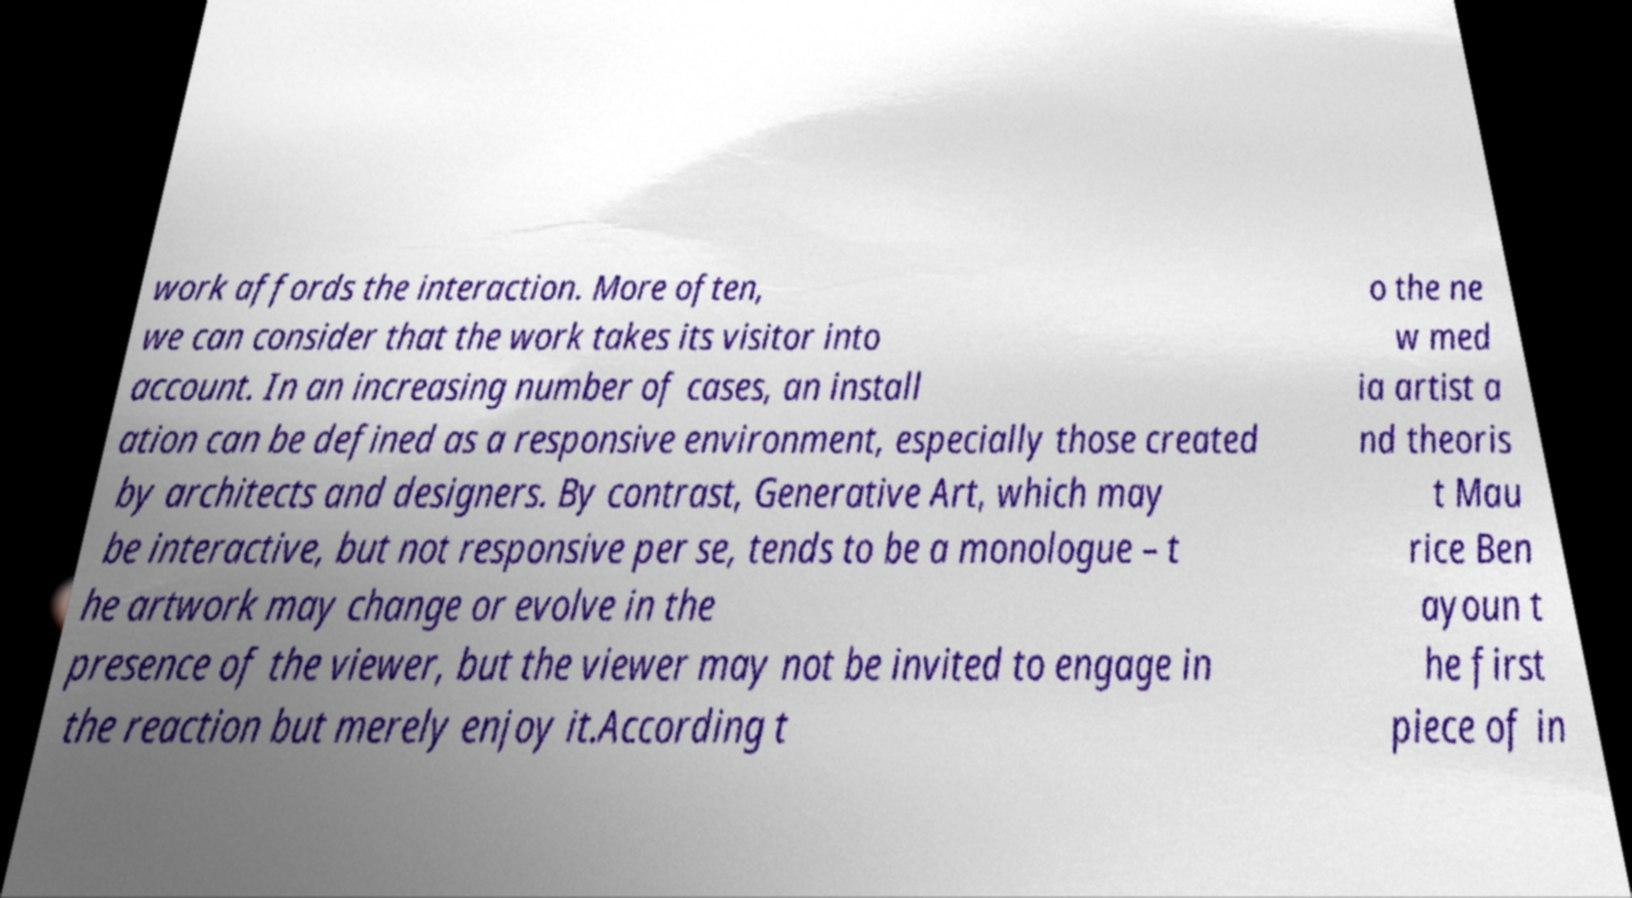What messages or text are displayed in this image? I need them in a readable, typed format. work affords the interaction. More often, we can consider that the work takes its visitor into account. In an increasing number of cases, an install ation can be defined as a responsive environment, especially those created by architects and designers. By contrast, Generative Art, which may be interactive, but not responsive per se, tends to be a monologue – t he artwork may change or evolve in the presence of the viewer, but the viewer may not be invited to engage in the reaction but merely enjoy it.According t o the ne w med ia artist a nd theoris t Mau rice Ben ayoun t he first piece of in 